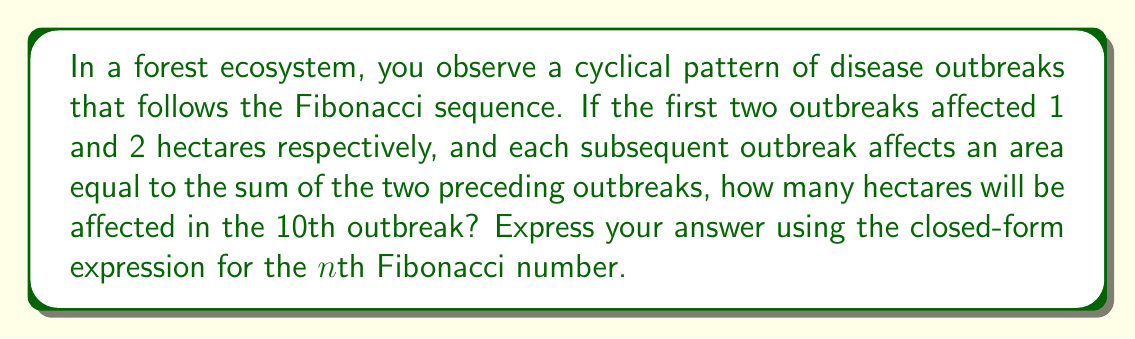What is the answer to this math problem? To solve this problem, we'll follow these steps:

1) First, let's recall the Fibonacci sequence: 1, 1, 2, 3, 5, 8, 13, 21, 34, 55, ...

2) In our case, the sequence starts with 1, 2 instead of 1, 1. However, this doesn't change the fundamental nature of the sequence.

3) We need to find the 10th term in this sequence.

4) The closed-form expression for the nth Fibonacci number is given by Binet's formula:

   $$F_n = \frac{\phi^n - (-\phi)^{-n}}{\sqrt{5}}$$

   where $\phi = \frac{1 + \sqrt{5}}{2}$ is the golden ratio.

5) In our case, we need to calculate $F_{11}$ (because our sequence starts at $n=0$).

6) Let's substitute $n=11$ into Binet's formula:

   $$F_{11} = \frac{\phi^{11} - (-\phi)^{-11}}{\sqrt{5}}$$

7) We can simplify this further:

   $$F_{11} = \frac{(\frac{1 + \sqrt{5}}{2})^{11} - (-\frac{1 + \sqrt{5}}{2})^{-11}}{\sqrt{5}}$$

This is the closed-form expression for the area affected by the 10th outbreak.
Answer: $$\frac{(\frac{1 + \sqrt{5}}{2})^{11} - (-\frac{1 + \sqrt{5}}{2})^{-11}}{\sqrt{5}}$$ hectares 